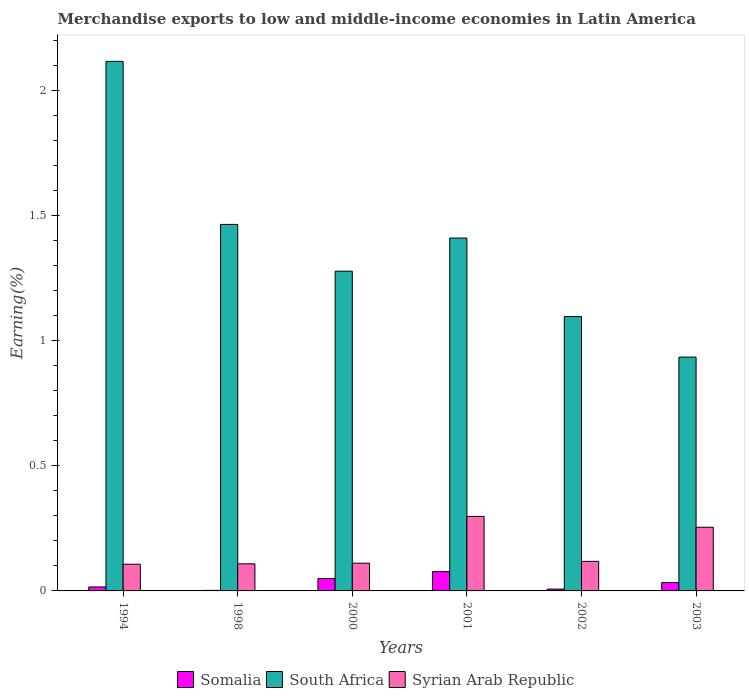How many groups of bars are there?
Ensure brevity in your answer.  6. What is the label of the 5th group of bars from the left?
Make the answer very short. 2002. What is the percentage of amount earned from merchandise exports in Somalia in 1998?
Provide a succinct answer. 0. Across all years, what is the maximum percentage of amount earned from merchandise exports in Syrian Arab Republic?
Provide a succinct answer. 0.3. Across all years, what is the minimum percentage of amount earned from merchandise exports in Syrian Arab Republic?
Make the answer very short. 0.11. What is the total percentage of amount earned from merchandise exports in South Africa in the graph?
Keep it short and to the point. 8.29. What is the difference between the percentage of amount earned from merchandise exports in South Africa in 2001 and that in 2003?
Provide a short and direct response. 0.48. What is the difference between the percentage of amount earned from merchandise exports in Somalia in 2003 and the percentage of amount earned from merchandise exports in South Africa in 2002?
Ensure brevity in your answer.  -1.06. What is the average percentage of amount earned from merchandise exports in Syrian Arab Republic per year?
Provide a succinct answer. 0.17. In the year 2001, what is the difference between the percentage of amount earned from merchandise exports in Somalia and percentage of amount earned from merchandise exports in South Africa?
Your response must be concise. -1.33. What is the ratio of the percentage of amount earned from merchandise exports in Syrian Arab Republic in 1994 to that in 2000?
Offer a terse response. 0.96. Is the percentage of amount earned from merchandise exports in Somalia in 2001 less than that in 2003?
Make the answer very short. No. What is the difference between the highest and the second highest percentage of amount earned from merchandise exports in South Africa?
Your answer should be compact. 0.65. What is the difference between the highest and the lowest percentage of amount earned from merchandise exports in South Africa?
Keep it short and to the point. 1.18. In how many years, is the percentage of amount earned from merchandise exports in Somalia greater than the average percentage of amount earned from merchandise exports in Somalia taken over all years?
Keep it short and to the point. 3. Is the sum of the percentage of amount earned from merchandise exports in Syrian Arab Republic in 1998 and 2003 greater than the maximum percentage of amount earned from merchandise exports in Somalia across all years?
Your response must be concise. Yes. What does the 1st bar from the left in 2003 represents?
Make the answer very short. Somalia. What does the 1st bar from the right in 2003 represents?
Provide a succinct answer. Syrian Arab Republic. Is it the case that in every year, the sum of the percentage of amount earned from merchandise exports in Somalia and percentage of amount earned from merchandise exports in South Africa is greater than the percentage of amount earned from merchandise exports in Syrian Arab Republic?
Your response must be concise. Yes. How many bars are there?
Keep it short and to the point. 18. How many years are there in the graph?
Make the answer very short. 6. What is the difference between two consecutive major ticks on the Y-axis?
Your answer should be very brief. 0.5. Does the graph contain any zero values?
Keep it short and to the point. No. Where does the legend appear in the graph?
Provide a succinct answer. Bottom center. How are the legend labels stacked?
Provide a succinct answer. Horizontal. What is the title of the graph?
Provide a short and direct response. Merchandise exports to low and middle-income economies in Latin America. Does "Brazil" appear as one of the legend labels in the graph?
Your response must be concise. No. What is the label or title of the Y-axis?
Provide a short and direct response. Earning(%). What is the Earning(%) in Somalia in 1994?
Make the answer very short. 0.02. What is the Earning(%) of South Africa in 1994?
Make the answer very short. 2.12. What is the Earning(%) in Syrian Arab Republic in 1994?
Ensure brevity in your answer.  0.11. What is the Earning(%) of Somalia in 1998?
Provide a short and direct response. 0. What is the Earning(%) of South Africa in 1998?
Offer a very short reply. 1.46. What is the Earning(%) in Syrian Arab Republic in 1998?
Give a very brief answer. 0.11. What is the Earning(%) in Somalia in 2000?
Offer a terse response. 0.05. What is the Earning(%) in South Africa in 2000?
Your answer should be compact. 1.28. What is the Earning(%) of Syrian Arab Republic in 2000?
Make the answer very short. 0.11. What is the Earning(%) of Somalia in 2001?
Offer a terse response. 0.08. What is the Earning(%) in South Africa in 2001?
Your answer should be very brief. 1.41. What is the Earning(%) in Syrian Arab Republic in 2001?
Keep it short and to the point. 0.3. What is the Earning(%) of Somalia in 2002?
Make the answer very short. 0.01. What is the Earning(%) in South Africa in 2002?
Your answer should be very brief. 1.1. What is the Earning(%) of Syrian Arab Republic in 2002?
Make the answer very short. 0.12. What is the Earning(%) of Somalia in 2003?
Your answer should be compact. 0.03. What is the Earning(%) of South Africa in 2003?
Ensure brevity in your answer.  0.93. What is the Earning(%) of Syrian Arab Republic in 2003?
Ensure brevity in your answer.  0.25. Across all years, what is the maximum Earning(%) of Somalia?
Your response must be concise. 0.08. Across all years, what is the maximum Earning(%) of South Africa?
Your answer should be very brief. 2.12. Across all years, what is the maximum Earning(%) of Syrian Arab Republic?
Offer a terse response. 0.3. Across all years, what is the minimum Earning(%) of Somalia?
Your answer should be compact. 0. Across all years, what is the minimum Earning(%) of South Africa?
Offer a terse response. 0.93. Across all years, what is the minimum Earning(%) in Syrian Arab Republic?
Your response must be concise. 0.11. What is the total Earning(%) of Somalia in the graph?
Your response must be concise. 0.19. What is the total Earning(%) in South Africa in the graph?
Offer a very short reply. 8.29. What is the total Earning(%) of Syrian Arab Republic in the graph?
Your response must be concise. 1. What is the difference between the Earning(%) in Somalia in 1994 and that in 1998?
Make the answer very short. 0.01. What is the difference between the Earning(%) in South Africa in 1994 and that in 1998?
Provide a succinct answer. 0.65. What is the difference between the Earning(%) in Syrian Arab Republic in 1994 and that in 1998?
Give a very brief answer. -0. What is the difference between the Earning(%) in Somalia in 1994 and that in 2000?
Provide a short and direct response. -0.03. What is the difference between the Earning(%) in South Africa in 1994 and that in 2000?
Your answer should be compact. 0.84. What is the difference between the Earning(%) of Syrian Arab Republic in 1994 and that in 2000?
Your answer should be very brief. -0. What is the difference between the Earning(%) in Somalia in 1994 and that in 2001?
Provide a succinct answer. -0.06. What is the difference between the Earning(%) of South Africa in 1994 and that in 2001?
Provide a succinct answer. 0.71. What is the difference between the Earning(%) of Syrian Arab Republic in 1994 and that in 2001?
Your answer should be compact. -0.19. What is the difference between the Earning(%) in Somalia in 1994 and that in 2002?
Keep it short and to the point. 0.01. What is the difference between the Earning(%) in South Africa in 1994 and that in 2002?
Give a very brief answer. 1.02. What is the difference between the Earning(%) in Syrian Arab Republic in 1994 and that in 2002?
Ensure brevity in your answer.  -0.01. What is the difference between the Earning(%) of Somalia in 1994 and that in 2003?
Your answer should be compact. -0.02. What is the difference between the Earning(%) of South Africa in 1994 and that in 2003?
Provide a succinct answer. 1.18. What is the difference between the Earning(%) of Syrian Arab Republic in 1994 and that in 2003?
Provide a succinct answer. -0.15. What is the difference between the Earning(%) in Somalia in 1998 and that in 2000?
Provide a succinct answer. -0.05. What is the difference between the Earning(%) in South Africa in 1998 and that in 2000?
Provide a succinct answer. 0.19. What is the difference between the Earning(%) of Syrian Arab Republic in 1998 and that in 2000?
Keep it short and to the point. -0. What is the difference between the Earning(%) in Somalia in 1998 and that in 2001?
Your answer should be compact. -0.07. What is the difference between the Earning(%) of South Africa in 1998 and that in 2001?
Ensure brevity in your answer.  0.05. What is the difference between the Earning(%) of Syrian Arab Republic in 1998 and that in 2001?
Make the answer very short. -0.19. What is the difference between the Earning(%) of Somalia in 1998 and that in 2002?
Make the answer very short. -0.01. What is the difference between the Earning(%) in South Africa in 1998 and that in 2002?
Your answer should be compact. 0.37. What is the difference between the Earning(%) of Syrian Arab Republic in 1998 and that in 2002?
Keep it short and to the point. -0.01. What is the difference between the Earning(%) of Somalia in 1998 and that in 2003?
Your response must be concise. -0.03. What is the difference between the Earning(%) of South Africa in 1998 and that in 2003?
Make the answer very short. 0.53. What is the difference between the Earning(%) of Syrian Arab Republic in 1998 and that in 2003?
Your answer should be very brief. -0.15. What is the difference between the Earning(%) in Somalia in 2000 and that in 2001?
Provide a short and direct response. -0.03. What is the difference between the Earning(%) in South Africa in 2000 and that in 2001?
Your response must be concise. -0.13. What is the difference between the Earning(%) of Syrian Arab Republic in 2000 and that in 2001?
Provide a short and direct response. -0.19. What is the difference between the Earning(%) of Somalia in 2000 and that in 2002?
Your answer should be compact. 0.04. What is the difference between the Earning(%) of South Africa in 2000 and that in 2002?
Give a very brief answer. 0.18. What is the difference between the Earning(%) of Syrian Arab Republic in 2000 and that in 2002?
Keep it short and to the point. -0.01. What is the difference between the Earning(%) of Somalia in 2000 and that in 2003?
Ensure brevity in your answer.  0.02. What is the difference between the Earning(%) of South Africa in 2000 and that in 2003?
Keep it short and to the point. 0.34. What is the difference between the Earning(%) of Syrian Arab Republic in 2000 and that in 2003?
Your answer should be compact. -0.14. What is the difference between the Earning(%) of Somalia in 2001 and that in 2002?
Your answer should be very brief. 0.07. What is the difference between the Earning(%) in South Africa in 2001 and that in 2002?
Your response must be concise. 0.31. What is the difference between the Earning(%) of Syrian Arab Republic in 2001 and that in 2002?
Offer a very short reply. 0.18. What is the difference between the Earning(%) of Somalia in 2001 and that in 2003?
Give a very brief answer. 0.04. What is the difference between the Earning(%) of South Africa in 2001 and that in 2003?
Your answer should be compact. 0.48. What is the difference between the Earning(%) of Syrian Arab Republic in 2001 and that in 2003?
Provide a short and direct response. 0.04. What is the difference between the Earning(%) in Somalia in 2002 and that in 2003?
Your answer should be very brief. -0.03. What is the difference between the Earning(%) in South Africa in 2002 and that in 2003?
Your answer should be very brief. 0.16. What is the difference between the Earning(%) in Syrian Arab Republic in 2002 and that in 2003?
Ensure brevity in your answer.  -0.14. What is the difference between the Earning(%) in Somalia in 1994 and the Earning(%) in South Africa in 1998?
Offer a terse response. -1.45. What is the difference between the Earning(%) in Somalia in 1994 and the Earning(%) in Syrian Arab Republic in 1998?
Offer a terse response. -0.09. What is the difference between the Earning(%) in South Africa in 1994 and the Earning(%) in Syrian Arab Republic in 1998?
Provide a short and direct response. 2.01. What is the difference between the Earning(%) in Somalia in 1994 and the Earning(%) in South Africa in 2000?
Make the answer very short. -1.26. What is the difference between the Earning(%) in Somalia in 1994 and the Earning(%) in Syrian Arab Republic in 2000?
Offer a terse response. -0.1. What is the difference between the Earning(%) of South Africa in 1994 and the Earning(%) of Syrian Arab Republic in 2000?
Make the answer very short. 2. What is the difference between the Earning(%) of Somalia in 1994 and the Earning(%) of South Africa in 2001?
Ensure brevity in your answer.  -1.39. What is the difference between the Earning(%) of Somalia in 1994 and the Earning(%) of Syrian Arab Republic in 2001?
Provide a succinct answer. -0.28. What is the difference between the Earning(%) in South Africa in 1994 and the Earning(%) in Syrian Arab Republic in 2001?
Ensure brevity in your answer.  1.82. What is the difference between the Earning(%) of Somalia in 1994 and the Earning(%) of South Africa in 2002?
Your answer should be very brief. -1.08. What is the difference between the Earning(%) of Somalia in 1994 and the Earning(%) of Syrian Arab Republic in 2002?
Your answer should be very brief. -0.1. What is the difference between the Earning(%) of South Africa in 1994 and the Earning(%) of Syrian Arab Republic in 2002?
Make the answer very short. 2. What is the difference between the Earning(%) of Somalia in 1994 and the Earning(%) of South Africa in 2003?
Your answer should be very brief. -0.92. What is the difference between the Earning(%) of Somalia in 1994 and the Earning(%) of Syrian Arab Republic in 2003?
Offer a terse response. -0.24. What is the difference between the Earning(%) in South Africa in 1994 and the Earning(%) in Syrian Arab Republic in 2003?
Provide a succinct answer. 1.86. What is the difference between the Earning(%) in Somalia in 1998 and the Earning(%) in South Africa in 2000?
Ensure brevity in your answer.  -1.27. What is the difference between the Earning(%) of Somalia in 1998 and the Earning(%) of Syrian Arab Republic in 2000?
Your answer should be very brief. -0.11. What is the difference between the Earning(%) of South Africa in 1998 and the Earning(%) of Syrian Arab Republic in 2000?
Your response must be concise. 1.35. What is the difference between the Earning(%) in Somalia in 1998 and the Earning(%) in South Africa in 2001?
Ensure brevity in your answer.  -1.41. What is the difference between the Earning(%) in Somalia in 1998 and the Earning(%) in Syrian Arab Republic in 2001?
Make the answer very short. -0.3. What is the difference between the Earning(%) of South Africa in 1998 and the Earning(%) of Syrian Arab Republic in 2001?
Make the answer very short. 1.17. What is the difference between the Earning(%) in Somalia in 1998 and the Earning(%) in South Africa in 2002?
Offer a terse response. -1.09. What is the difference between the Earning(%) of Somalia in 1998 and the Earning(%) of Syrian Arab Republic in 2002?
Your answer should be very brief. -0.12. What is the difference between the Earning(%) of South Africa in 1998 and the Earning(%) of Syrian Arab Republic in 2002?
Provide a short and direct response. 1.35. What is the difference between the Earning(%) in Somalia in 1998 and the Earning(%) in South Africa in 2003?
Your answer should be very brief. -0.93. What is the difference between the Earning(%) of Somalia in 1998 and the Earning(%) of Syrian Arab Republic in 2003?
Your answer should be very brief. -0.25. What is the difference between the Earning(%) in South Africa in 1998 and the Earning(%) in Syrian Arab Republic in 2003?
Ensure brevity in your answer.  1.21. What is the difference between the Earning(%) of Somalia in 2000 and the Earning(%) of South Africa in 2001?
Ensure brevity in your answer.  -1.36. What is the difference between the Earning(%) of Somalia in 2000 and the Earning(%) of Syrian Arab Republic in 2001?
Offer a terse response. -0.25. What is the difference between the Earning(%) in South Africa in 2000 and the Earning(%) in Syrian Arab Republic in 2001?
Keep it short and to the point. 0.98. What is the difference between the Earning(%) of Somalia in 2000 and the Earning(%) of South Africa in 2002?
Make the answer very short. -1.05. What is the difference between the Earning(%) of Somalia in 2000 and the Earning(%) of Syrian Arab Republic in 2002?
Your answer should be compact. -0.07. What is the difference between the Earning(%) of South Africa in 2000 and the Earning(%) of Syrian Arab Republic in 2002?
Your response must be concise. 1.16. What is the difference between the Earning(%) in Somalia in 2000 and the Earning(%) in South Africa in 2003?
Provide a short and direct response. -0.88. What is the difference between the Earning(%) in Somalia in 2000 and the Earning(%) in Syrian Arab Republic in 2003?
Make the answer very short. -0.2. What is the difference between the Earning(%) of South Africa in 2000 and the Earning(%) of Syrian Arab Republic in 2003?
Keep it short and to the point. 1.02. What is the difference between the Earning(%) in Somalia in 2001 and the Earning(%) in South Africa in 2002?
Make the answer very short. -1.02. What is the difference between the Earning(%) of Somalia in 2001 and the Earning(%) of Syrian Arab Republic in 2002?
Your answer should be compact. -0.04. What is the difference between the Earning(%) in South Africa in 2001 and the Earning(%) in Syrian Arab Republic in 2002?
Make the answer very short. 1.29. What is the difference between the Earning(%) in Somalia in 2001 and the Earning(%) in South Africa in 2003?
Give a very brief answer. -0.86. What is the difference between the Earning(%) in Somalia in 2001 and the Earning(%) in Syrian Arab Republic in 2003?
Your answer should be very brief. -0.18. What is the difference between the Earning(%) in South Africa in 2001 and the Earning(%) in Syrian Arab Republic in 2003?
Offer a terse response. 1.16. What is the difference between the Earning(%) of Somalia in 2002 and the Earning(%) of South Africa in 2003?
Ensure brevity in your answer.  -0.93. What is the difference between the Earning(%) of Somalia in 2002 and the Earning(%) of Syrian Arab Republic in 2003?
Offer a terse response. -0.25. What is the difference between the Earning(%) in South Africa in 2002 and the Earning(%) in Syrian Arab Republic in 2003?
Your answer should be compact. 0.84. What is the average Earning(%) in Somalia per year?
Keep it short and to the point. 0.03. What is the average Earning(%) in South Africa per year?
Offer a terse response. 1.38. What is the average Earning(%) in Syrian Arab Republic per year?
Your answer should be compact. 0.17. In the year 1994, what is the difference between the Earning(%) in Somalia and Earning(%) in South Africa?
Your response must be concise. -2.1. In the year 1994, what is the difference between the Earning(%) in Somalia and Earning(%) in Syrian Arab Republic?
Your answer should be very brief. -0.09. In the year 1994, what is the difference between the Earning(%) in South Africa and Earning(%) in Syrian Arab Republic?
Ensure brevity in your answer.  2.01. In the year 1998, what is the difference between the Earning(%) of Somalia and Earning(%) of South Africa?
Offer a terse response. -1.46. In the year 1998, what is the difference between the Earning(%) in Somalia and Earning(%) in Syrian Arab Republic?
Keep it short and to the point. -0.11. In the year 1998, what is the difference between the Earning(%) of South Africa and Earning(%) of Syrian Arab Republic?
Your answer should be very brief. 1.36. In the year 2000, what is the difference between the Earning(%) in Somalia and Earning(%) in South Africa?
Your answer should be compact. -1.23. In the year 2000, what is the difference between the Earning(%) in Somalia and Earning(%) in Syrian Arab Republic?
Offer a terse response. -0.06. In the year 2000, what is the difference between the Earning(%) in South Africa and Earning(%) in Syrian Arab Republic?
Offer a very short reply. 1.17. In the year 2001, what is the difference between the Earning(%) of Somalia and Earning(%) of South Africa?
Provide a succinct answer. -1.33. In the year 2001, what is the difference between the Earning(%) of Somalia and Earning(%) of Syrian Arab Republic?
Ensure brevity in your answer.  -0.22. In the year 2001, what is the difference between the Earning(%) of South Africa and Earning(%) of Syrian Arab Republic?
Provide a short and direct response. 1.11. In the year 2002, what is the difference between the Earning(%) in Somalia and Earning(%) in South Africa?
Your answer should be compact. -1.09. In the year 2002, what is the difference between the Earning(%) of Somalia and Earning(%) of Syrian Arab Republic?
Keep it short and to the point. -0.11. In the year 2002, what is the difference between the Earning(%) in South Africa and Earning(%) in Syrian Arab Republic?
Offer a very short reply. 0.98. In the year 2003, what is the difference between the Earning(%) in Somalia and Earning(%) in South Africa?
Ensure brevity in your answer.  -0.9. In the year 2003, what is the difference between the Earning(%) in Somalia and Earning(%) in Syrian Arab Republic?
Ensure brevity in your answer.  -0.22. In the year 2003, what is the difference between the Earning(%) of South Africa and Earning(%) of Syrian Arab Republic?
Ensure brevity in your answer.  0.68. What is the ratio of the Earning(%) in Somalia in 1994 to that in 1998?
Your answer should be compact. 7.45. What is the ratio of the Earning(%) of South Africa in 1994 to that in 1998?
Offer a terse response. 1.44. What is the ratio of the Earning(%) in Syrian Arab Republic in 1994 to that in 1998?
Your answer should be very brief. 0.99. What is the ratio of the Earning(%) of Somalia in 1994 to that in 2000?
Your response must be concise. 0.32. What is the ratio of the Earning(%) of South Africa in 1994 to that in 2000?
Ensure brevity in your answer.  1.66. What is the ratio of the Earning(%) in Syrian Arab Republic in 1994 to that in 2000?
Offer a very short reply. 0.96. What is the ratio of the Earning(%) in Somalia in 1994 to that in 2001?
Ensure brevity in your answer.  0.2. What is the ratio of the Earning(%) of South Africa in 1994 to that in 2001?
Offer a very short reply. 1.5. What is the ratio of the Earning(%) in Syrian Arab Republic in 1994 to that in 2001?
Ensure brevity in your answer.  0.36. What is the ratio of the Earning(%) in Somalia in 1994 to that in 2002?
Provide a succinct answer. 2.15. What is the ratio of the Earning(%) of South Africa in 1994 to that in 2002?
Offer a very short reply. 1.93. What is the ratio of the Earning(%) in Syrian Arab Republic in 1994 to that in 2002?
Provide a succinct answer. 0.9. What is the ratio of the Earning(%) of Somalia in 1994 to that in 2003?
Your response must be concise. 0.47. What is the ratio of the Earning(%) in South Africa in 1994 to that in 2003?
Keep it short and to the point. 2.27. What is the ratio of the Earning(%) in Syrian Arab Republic in 1994 to that in 2003?
Offer a terse response. 0.42. What is the ratio of the Earning(%) of Somalia in 1998 to that in 2000?
Offer a terse response. 0.04. What is the ratio of the Earning(%) of South Africa in 1998 to that in 2000?
Your answer should be compact. 1.15. What is the ratio of the Earning(%) of Syrian Arab Republic in 1998 to that in 2000?
Offer a terse response. 0.98. What is the ratio of the Earning(%) of Somalia in 1998 to that in 2001?
Provide a succinct answer. 0.03. What is the ratio of the Earning(%) in South Africa in 1998 to that in 2001?
Offer a very short reply. 1.04. What is the ratio of the Earning(%) in Syrian Arab Republic in 1998 to that in 2001?
Keep it short and to the point. 0.36. What is the ratio of the Earning(%) of Somalia in 1998 to that in 2002?
Give a very brief answer. 0.29. What is the ratio of the Earning(%) in South Africa in 1998 to that in 2002?
Your answer should be compact. 1.34. What is the ratio of the Earning(%) of Syrian Arab Republic in 1998 to that in 2002?
Keep it short and to the point. 0.92. What is the ratio of the Earning(%) in Somalia in 1998 to that in 2003?
Your response must be concise. 0.06. What is the ratio of the Earning(%) in South Africa in 1998 to that in 2003?
Your answer should be compact. 1.57. What is the ratio of the Earning(%) of Syrian Arab Republic in 1998 to that in 2003?
Make the answer very short. 0.43. What is the ratio of the Earning(%) of Somalia in 2000 to that in 2001?
Your answer should be very brief. 0.64. What is the ratio of the Earning(%) of South Africa in 2000 to that in 2001?
Your answer should be compact. 0.91. What is the ratio of the Earning(%) in Syrian Arab Republic in 2000 to that in 2001?
Offer a very short reply. 0.37. What is the ratio of the Earning(%) in Somalia in 2000 to that in 2002?
Your response must be concise. 6.73. What is the ratio of the Earning(%) of South Africa in 2000 to that in 2002?
Provide a succinct answer. 1.17. What is the ratio of the Earning(%) of Syrian Arab Republic in 2000 to that in 2002?
Offer a terse response. 0.94. What is the ratio of the Earning(%) of Somalia in 2000 to that in 2003?
Your answer should be very brief. 1.48. What is the ratio of the Earning(%) of South Africa in 2000 to that in 2003?
Give a very brief answer. 1.37. What is the ratio of the Earning(%) of Syrian Arab Republic in 2000 to that in 2003?
Provide a short and direct response. 0.44. What is the ratio of the Earning(%) of Somalia in 2001 to that in 2002?
Give a very brief answer. 10.51. What is the ratio of the Earning(%) in South Africa in 2001 to that in 2002?
Your answer should be compact. 1.29. What is the ratio of the Earning(%) in Syrian Arab Republic in 2001 to that in 2002?
Make the answer very short. 2.52. What is the ratio of the Earning(%) of Somalia in 2001 to that in 2003?
Offer a very short reply. 2.31. What is the ratio of the Earning(%) of South Africa in 2001 to that in 2003?
Provide a short and direct response. 1.51. What is the ratio of the Earning(%) in Syrian Arab Republic in 2001 to that in 2003?
Provide a succinct answer. 1.17. What is the ratio of the Earning(%) of Somalia in 2002 to that in 2003?
Offer a terse response. 0.22. What is the ratio of the Earning(%) in South Africa in 2002 to that in 2003?
Provide a short and direct response. 1.17. What is the ratio of the Earning(%) in Syrian Arab Republic in 2002 to that in 2003?
Your answer should be very brief. 0.46. What is the difference between the highest and the second highest Earning(%) of Somalia?
Your answer should be very brief. 0.03. What is the difference between the highest and the second highest Earning(%) of South Africa?
Make the answer very short. 0.65. What is the difference between the highest and the second highest Earning(%) of Syrian Arab Republic?
Make the answer very short. 0.04. What is the difference between the highest and the lowest Earning(%) in Somalia?
Offer a terse response. 0.07. What is the difference between the highest and the lowest Earning(%) of South Africa?
Offer a very short reply. 1.18. What is the difference between the highest and the lowest Earning(%) in Syrian Arab Republic?
Ensure brevity in your answer.  0.19. 